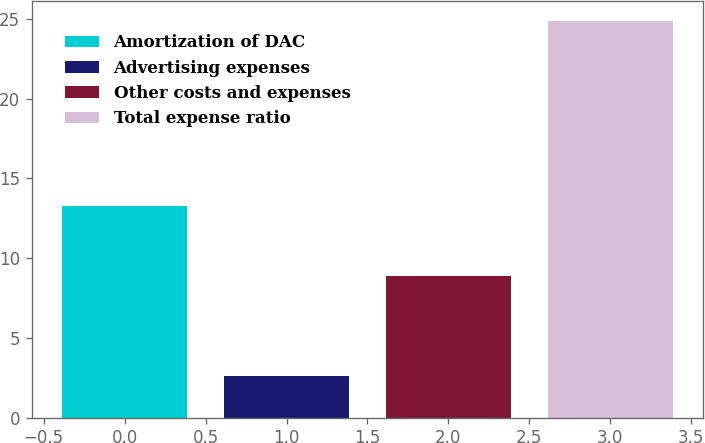Convert chart to OTSL. <chart><loc_0><loc_0><loc_500><loc_500><bar_chart><fcel>Amortization of DAC<fcel>Advertising expenses<fcel>Other costs and expenses<fcel>Total expense ratio<nl><fcel>13.3<fcel>2.6<fcel>8.9<fcel>24.9<nl></chart> 